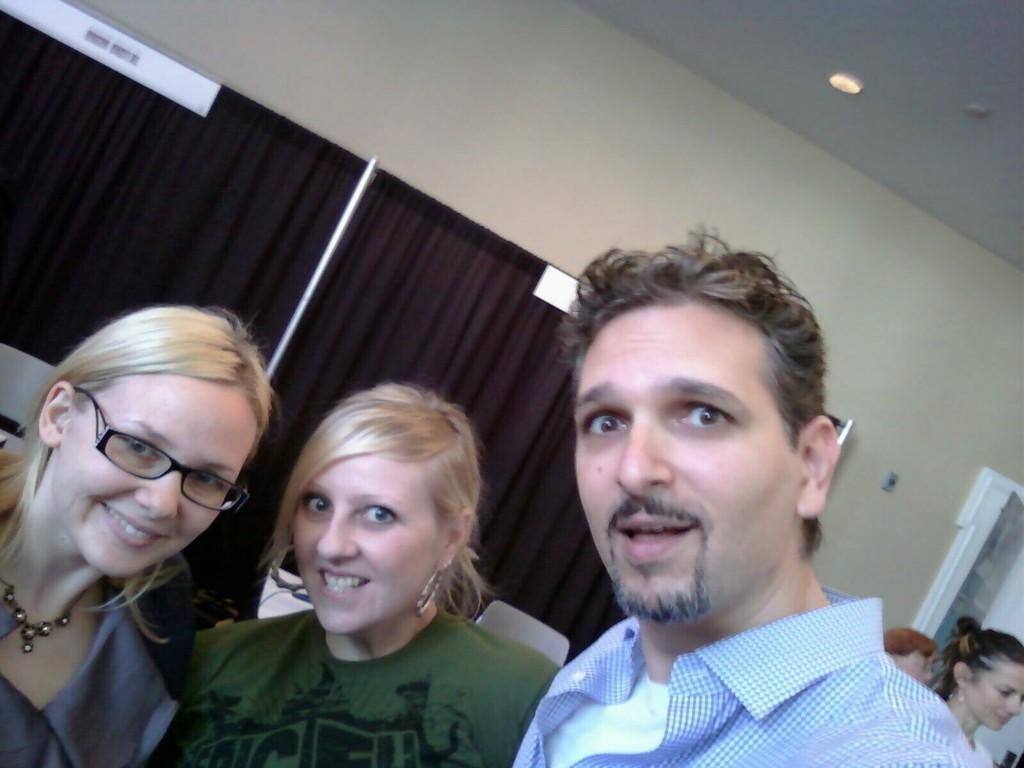How many people are in the front of the image? There are 3 people in the front of the image. Can you describe the people on the right side of the image? There are other people on the right side of the image. What type of curtains are present at the back of the image? There are black curtains at the back of the image. What is located at the top of the image? There are lights at the top of the image. What type of cheese is being served on the dock in the image? There is no dock or cheese present in the image. 